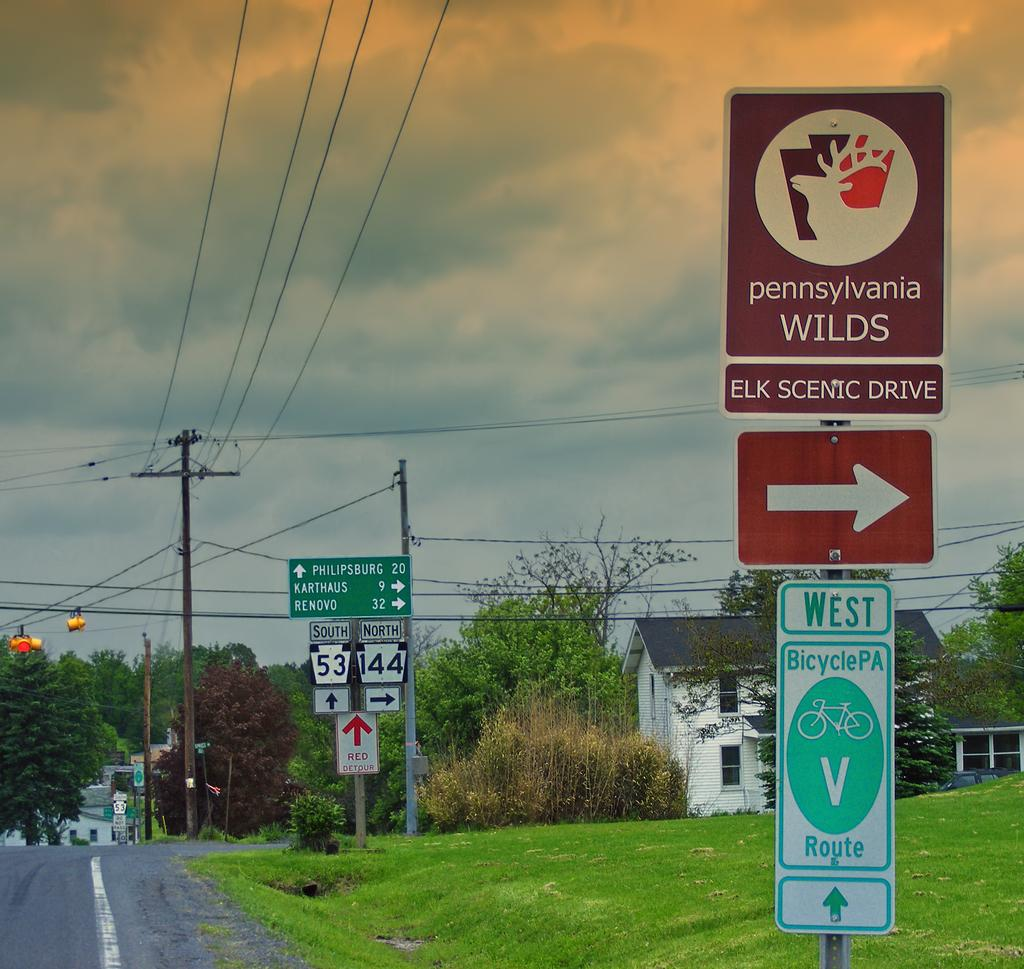<image>
Provide a brief description of the given image. the elk scenic drive is on the next right along with karthaus and renovo, philipsburg is straight ahead 